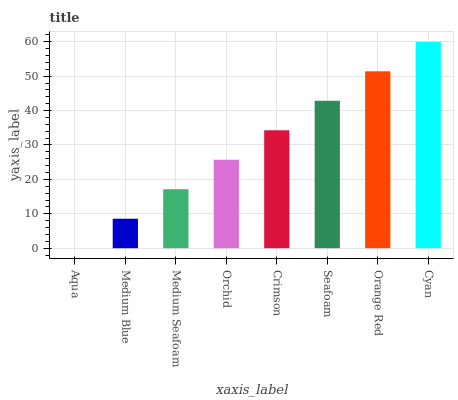Is Medium Blue the minimum?
Answer yes or no. No. Is Medium Blue the maximum?
Answer yes or no. No. Is Medium Blue greater than Aqua?
Answer yes or no. Yes. Is Aqua less than Medium Blue?
Answer yes or no. Yes. Is Aqua greater than Medium Blue?
Answer yes or no. No. Is Medium Blue less than Aqua?
Answer yes or no. No. Is Crimson the high median?
Answer yes or no. Yes. Is Orchid the low median?
Answer yes or no. Yes. Is Orchid the high median?
Answer yes or no. No. Is Cyan the low median?
Answer yes or no. No. 